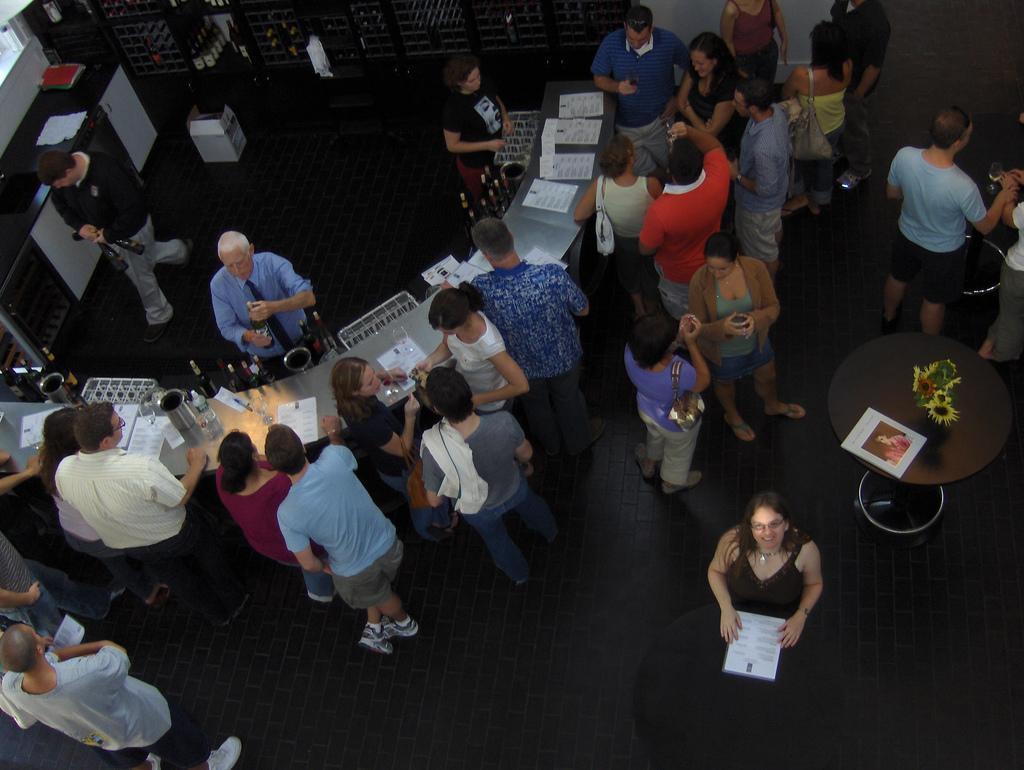How many women are looking up at the camera?
Give a very brief answer. 1. How many men are wearing ties?
Give a very brief answer. 1. How many sleeves does the man in the tie have rolled up?
Give a very brief answer. 1. How many people are behind the bar?
Give a very brief answer. 3. How many people are shown behind the counter?
Give a very brief answer. 3. 